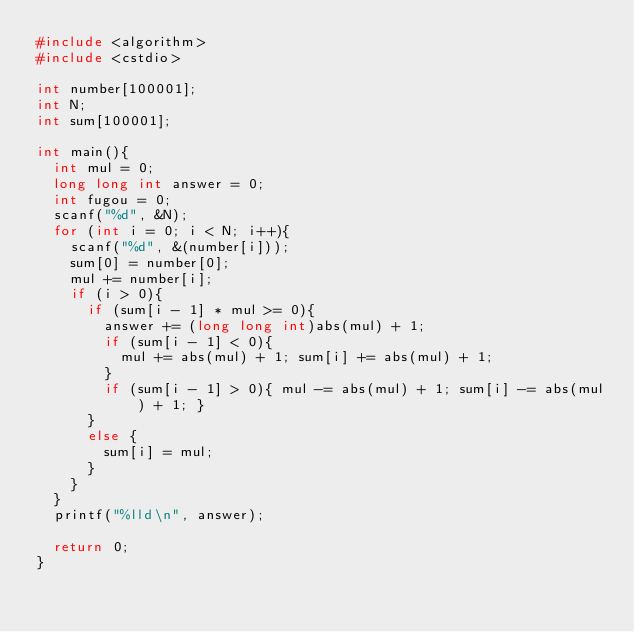Convert code to text. <code><loc_0><loc_0><loc_500><loc_500><_C++_>#include <algorithm>
#include <cstdio>

int number[100001];
int N;
int sum[100001];

int main(){
	int mul = 0;
	long long int answer = 0;
	int fugou = 0;
	scanf("%d", &N);
	for (int i = 0; i < N; i++){
		scanf("%d", &(number[i]));
		sum[0] = number[0];
		mul += number[i];
		if (i > 0){
			if (sum[i - 1] * mul >= 0){
				answer += (long long int)abs(mul) + 1;
				if (sum[i - 1] < 0){
					mul += abs(mul) + 1; sum[i] += abs(mul) + 1;
				}
				if (sum[i - 1] > 0){ mul -= abs(mul) + 1; sum[i] -= abs(mul) + 1; }
			}
			else {
				sum[i] = mul;
			}
		}
	}
	printf("%lld\n", answer);

	return 0;
}</code> 